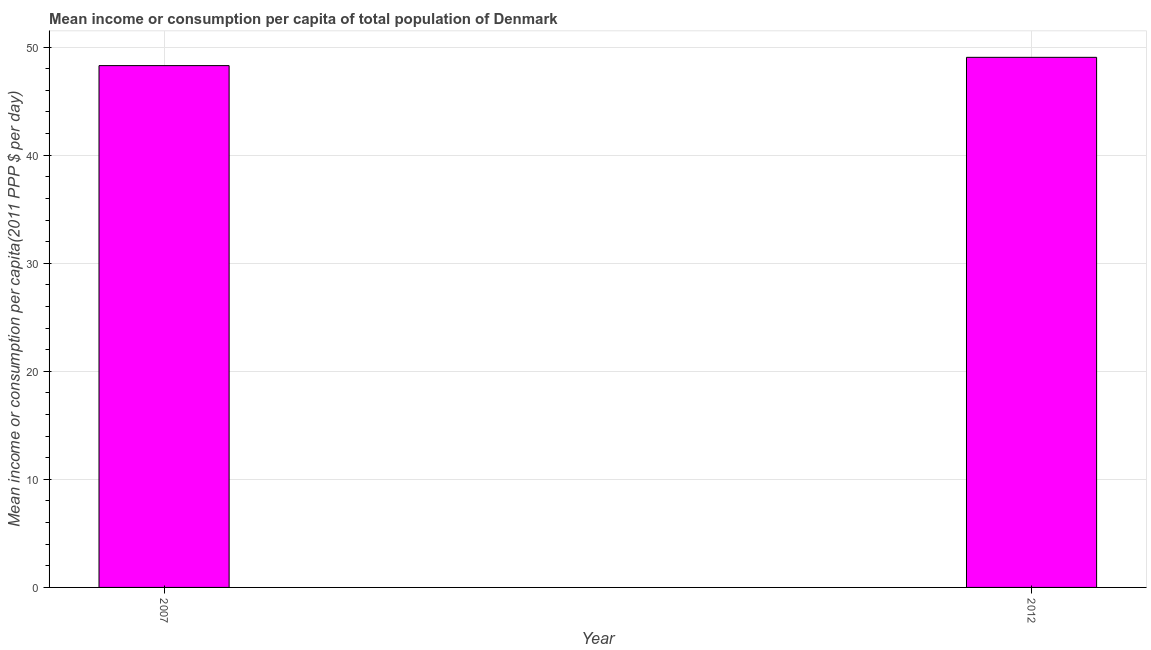Does the graph contain any zero values?
Give a very brief answer. No. What is the title of the graph?
Give a very brief answer. Mean income or consumption per capita of total population of Denmark. What is the label or title of the X-axis?
Ensure brevity in your answer.  Year. What is the label or title of the Y-axis?
Provide a succinct answer. Mean income or consumption per capita(2011 PPP $ per day). What is the mean income or consumption in 2012?
Offer a very short reply. 49.05. Across all years, what is the maximum mean income or consumption?
Your response must be concise. 49.05. Across all years, what is the minimum mean income or consumption?
Ensure brevity in your answer.  48.29. What is the sum of the mean income or consumption?
Offer a terse response. 97.34. What is the difference between the mean income or consumption in 2007 and 2012?
Ensure brevity in your answer.  -0.77. What is the average mean income or consumption per year?
Give a very brief answer. 48.67. What is the median mean income or consumption?
Keep it short and to the point. 48.67. Do a majority of the years between 2007 and 2012 (inclusive) have mean income or consumption greater than 4 $?
Offer a terse response. Yes. What is the ratio of the mean income or consumption in 2007 to that in 2012?
Your answer should be compact. 0.98. How many bars are there?
Give a very brief answer. 2. Are all the bars in the graph horizontal?
Provide a succinct answer. No. Are the values on the major ticks of Y-axis written in scientific E-notation?
Offer a terse response. No. What is the Mean income or consumption per capita(2011 PPP $ per day) in 2007?
Make the answer very short. 48.29. What is the Mean income or consumption per capita(2011 PPP $ per day) in 2012?
Give a very brief answer. 49.05. What is the difference between the Mean income or consumption per capita(2011 PPP $ per day) in 2007 and 2012?
Ensure brevity in your answer.  -0.77. 